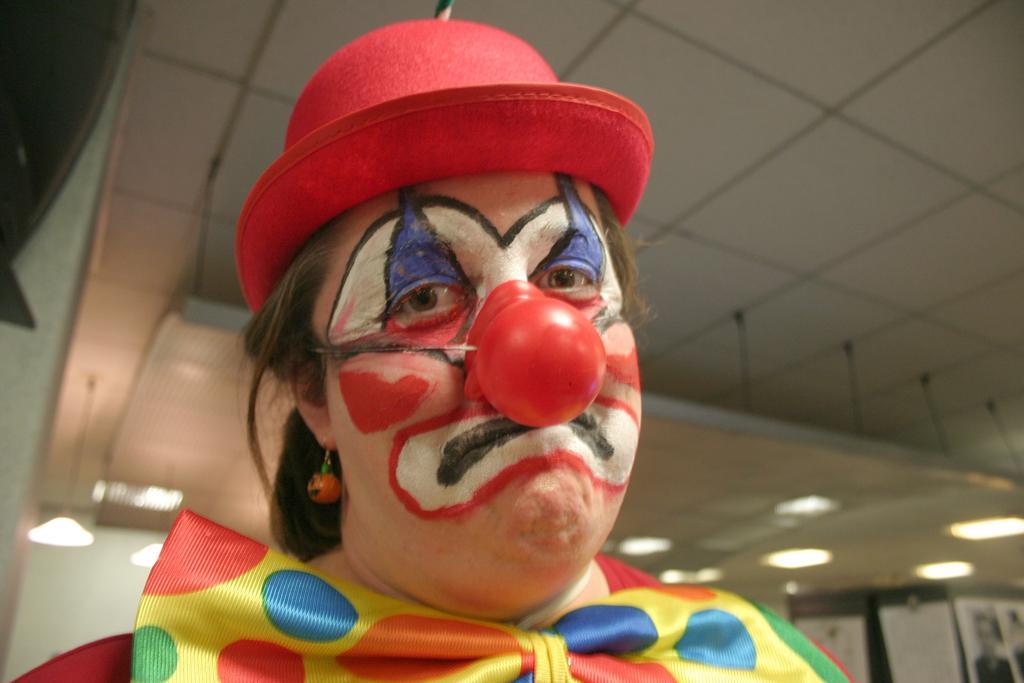In one or two sentences, can you explain what this image depicts? In this image we can see a person with face paint and wearing red color hat, earring and a different costume. The background of the image is slightly blurred, where we can see posters on the wall and lights to the ceiling. 